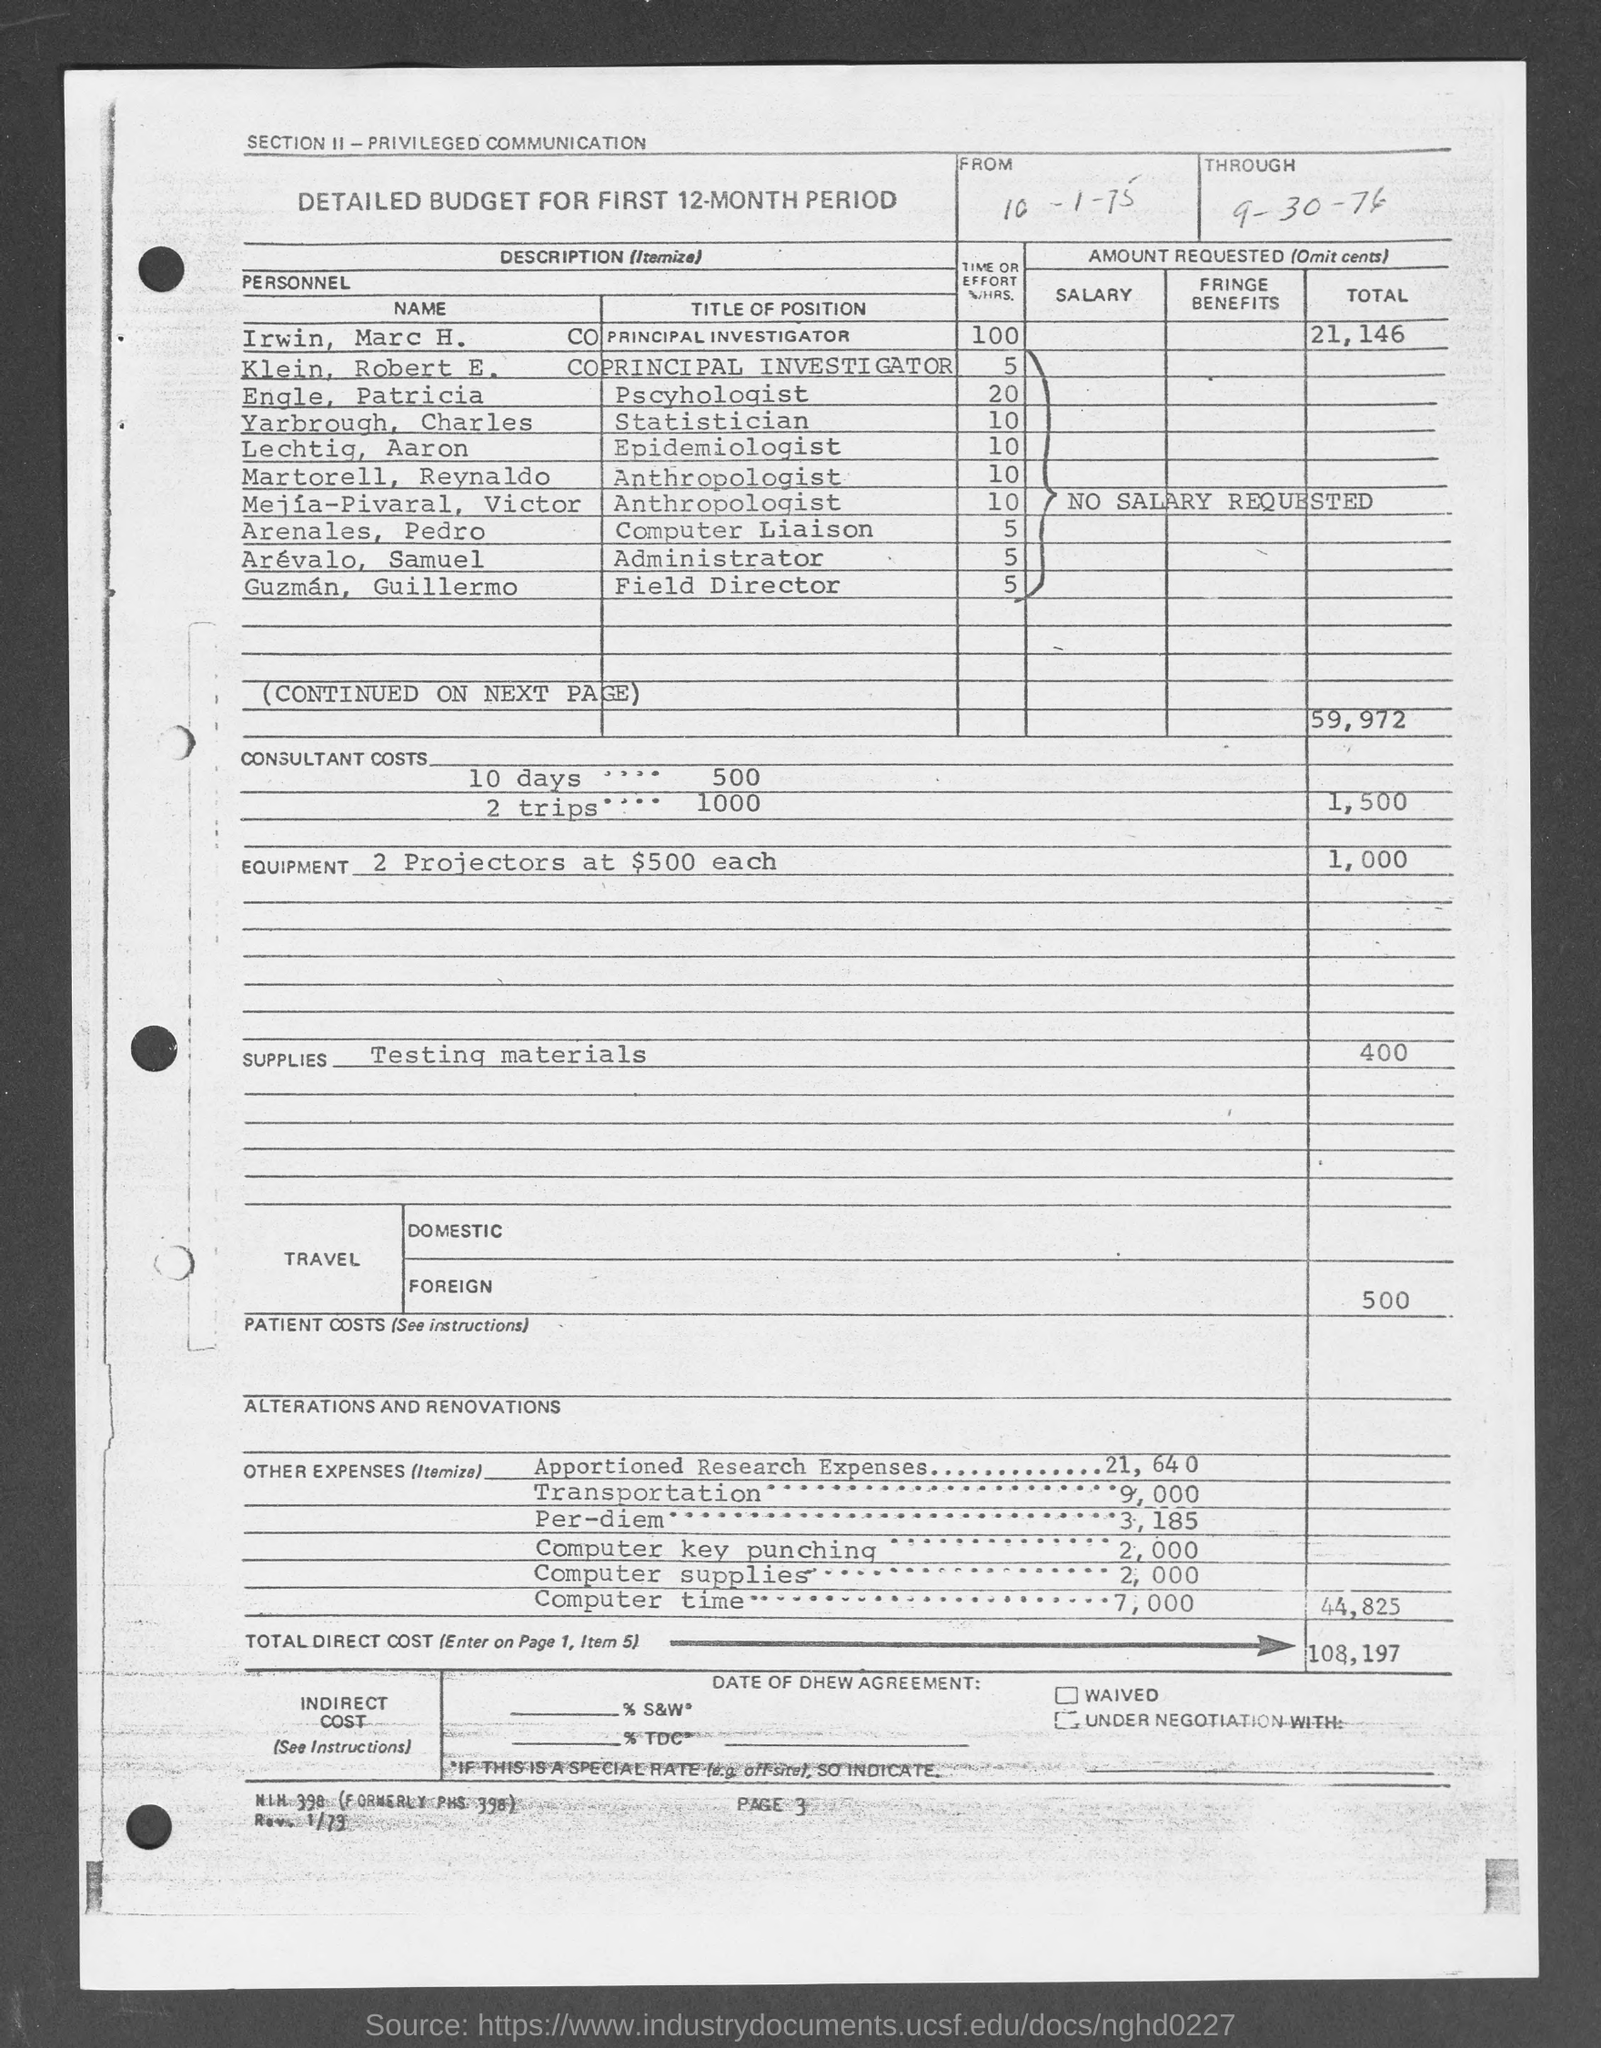Highlight a few significant elements in this photo. The consultant costs for two trips are 1000. The cost for a consultant for 10 days is $500. The costs associated with foreign travel can vary depending on a number of factors, including the destination, duration of the trip, mode of transportation, and accommodations. According to a recent estimate, the cost of traveling abroad may range from $500 to $5,000 or more, depending on the specific circumstances of the trip. The cost for two projectors, each priced at $500, is $1,000 in total. The cost for testing materials is 400. 